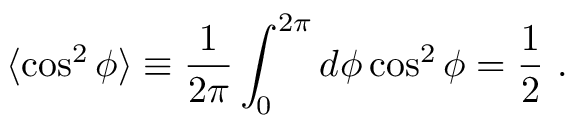Convert formula to latex. <formula><loc_0><loc_0><loc_500><loc_500>\langle \cos ^ { 2 } \phi \rangle \equiv \frac { 1 } { 2 \pi } \int _ { 0 } ^ { 2 \pi } d \phi \cos ^ { 2 } \phi = \frac { 1 } { 2 } \ .</formula> 